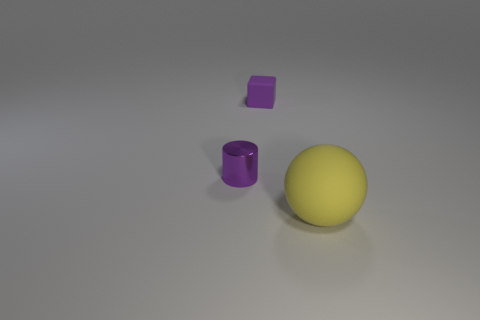Is there any other thing that is the same size as the metallic cylinder? Based on the image, the purple cube appears to be similar in size to the metallic cylinder. Their dimensions are not identical, but visually, they are comparable in volume. 